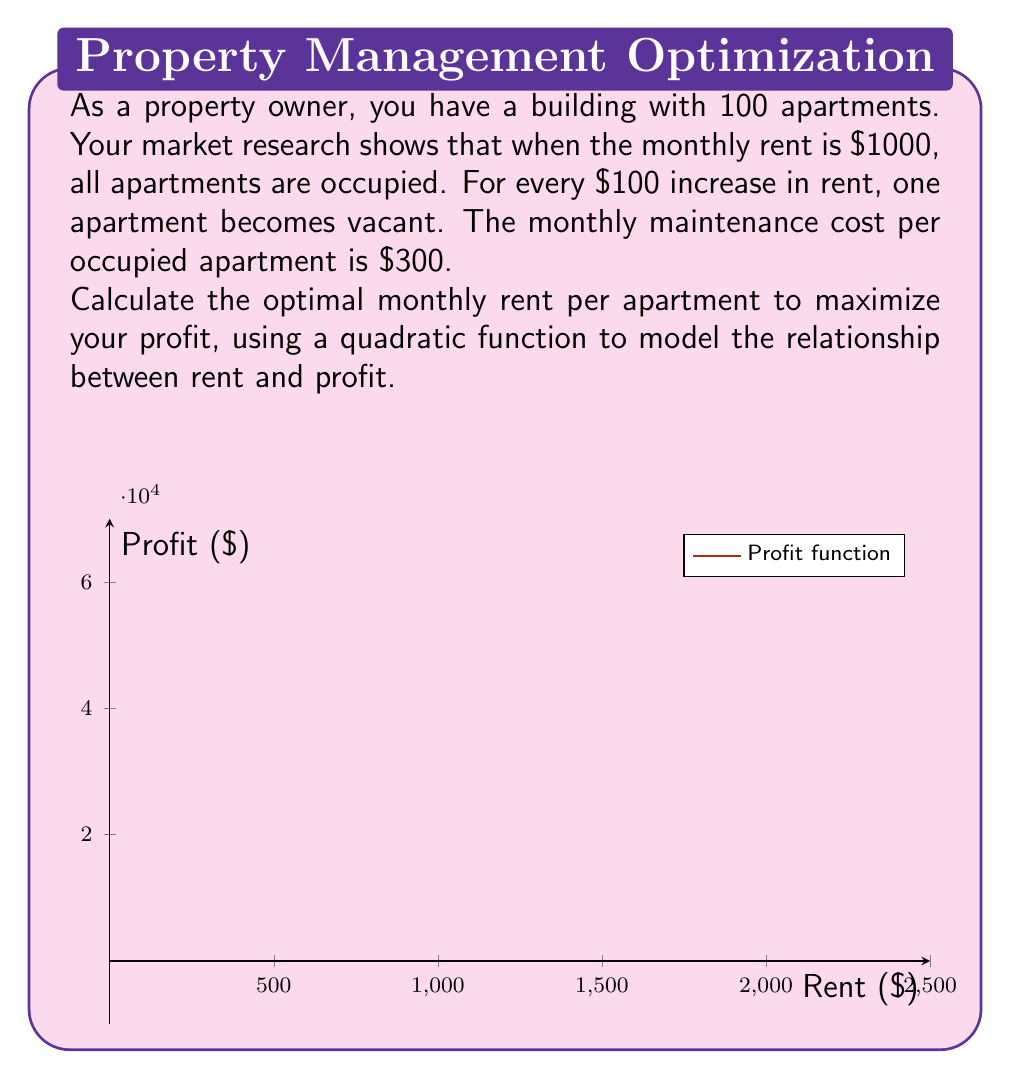Provide a solution to this math problem. Let's approach this step-by-step:

1) Let $x$ be the rent in hundreds of dollars. When $x = 10$ (i.e., $1000), all 100 apartments are occupied.

2) Number of occupied apartments: $y = 100 - (x - 10) = 110 - x$

3) Total revenue: $R = xy = x(110 - x) = 110x - x^2$

4) Total maintenance cost: $C = 300(110 - x) = 33000 - 300x$

5) Profit function: $P = R - C = 110x - x^2 - (33000 - 300x)$
                               $= 110x - x^2 - 33000 + 300x$
                               $= -x^2 + 410x - 33000$

6) To find the maximum profit, we need to find the vertex of this quadratic function.

7) The x-coordinate of the vertex is given by $x = -b/(2a)$, where $a$ and $b$ are the coefficients of $x^2$ and $x$ respectively.

8) $x = -410 / (2(-1)) = 205$

9) This means the optimal rent is $205 * 100 = $2050$

10) To verify, we can calculate the second derivative: $P''(x) = -2 < 0$, confirming this is indeed a maximum.
Answer: $2050 per month 